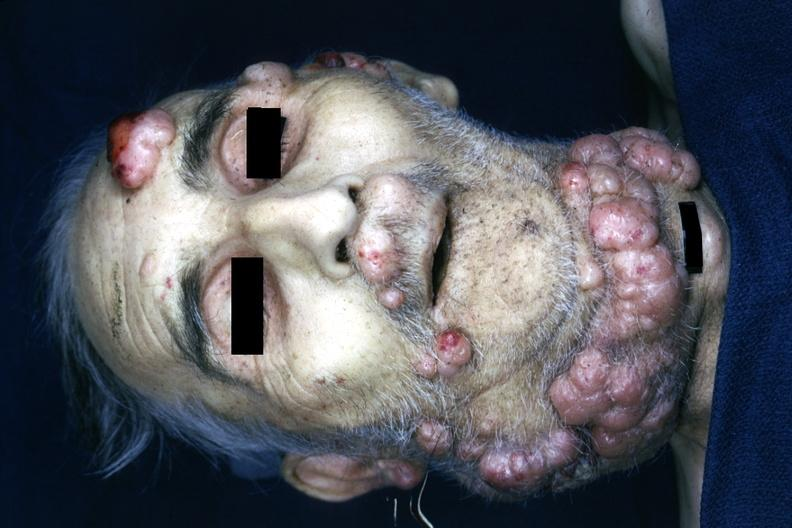what is present?
Answer the question using a single word or phrase. Face 